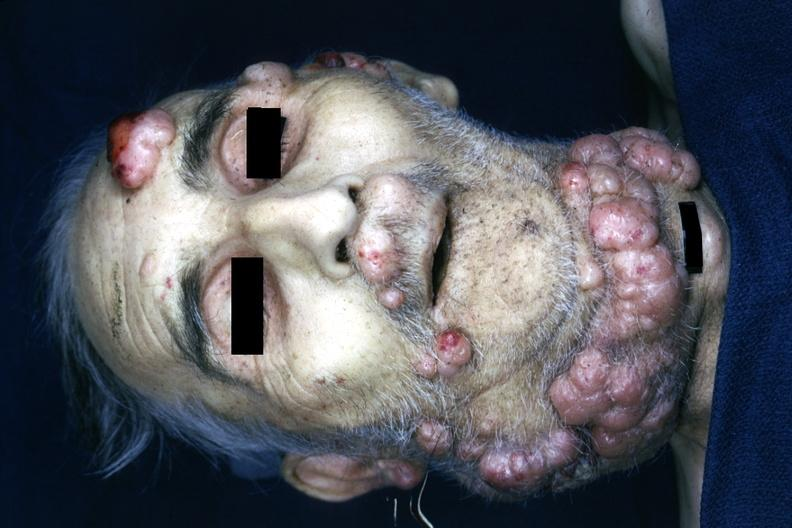what is present?
Answer the question using a single word or phrase. Face 